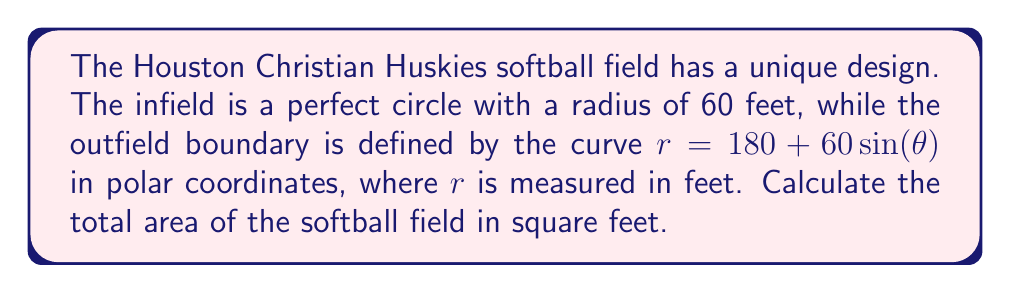Show me your answer to this math problem. Let's approach this step-by-step:

1) First, we need to calculate the area of the circular infield:
   $$A_{infield} = \pi r^2 = \pi (60)^2 = 3600\pi \text{ sq ft}$$

2) For the outfield, we need to use the formula for area in polar coordinates:
   $$A_{outfield} = \frac{1}{2} \int_0^{2\pi} r^2 d\theta$$

3) Substituting our curve equation:
   $$A_{outfield} = \frac{1}{2} \int_0^{2\pi} (180 + 60\sin(\theta))^2 d\theta$$

4) Expanding the squared term:
   $$A_{outfield} = \frac{1}{2} \int_0^{2\pi} (32400 + 21600\sin(\theta) + 3600\sin^2(\theta)) d\theta$$

5) Integrating term by term:
   $$A_{outfield} = \frac{1}{2} [32400\theta + 21600(-\cos(\theta)) + 3600(\frac{\theta}{2} - \frac{\sin(2\theta)}{4})]_0^{2\pi}$$

6) Evaluating at the limits:
   $$A_{outfield} = \frac{1}{2} (64800\pi + 3600\pi) = 34200\pi \text{ sq ft}$$

7) The total area is the sum of infield and outfield:
   $$A_{total} = A_{infield} + A_{outfield} = 3600\pi + 34200\pi = 37800\pi \text{ sq ft}$$
Answer: $37800\pi$ sq ft 